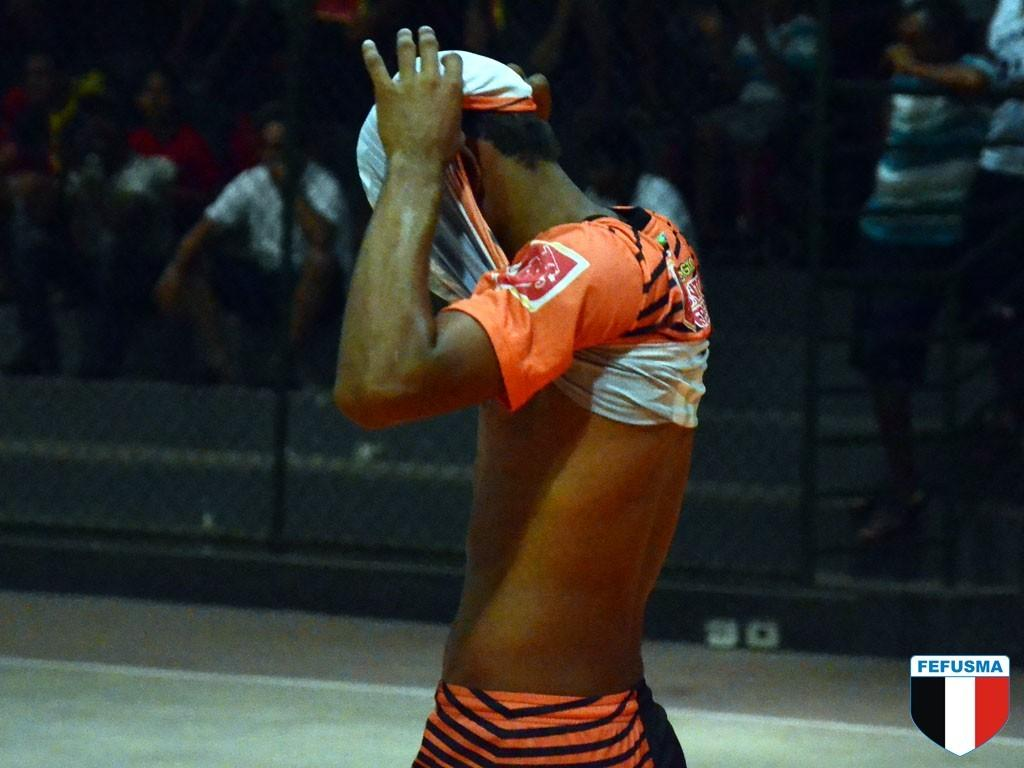<image>
Offer a succinct explanation of the picture presented. A man has his shirt pulled over his face and there is a FEFUSMA crest in the corner. 